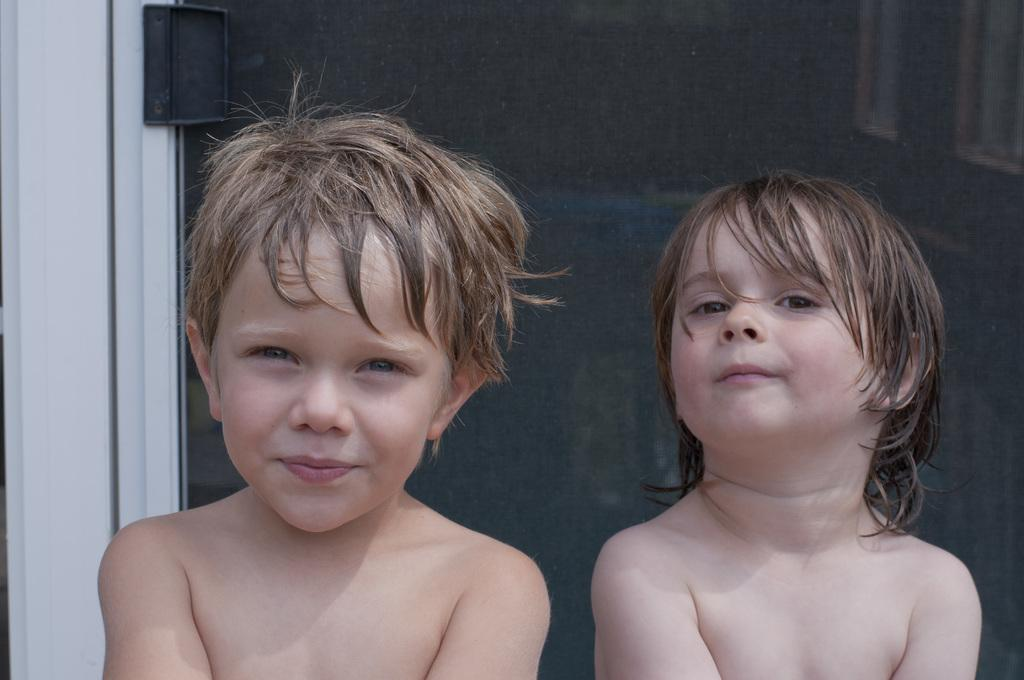How many children are present in the image? There are two children in the image. What is visible behind the children in the image? There is a glass door visible in the image. What type of pancake is being served on the edge of the vest in the image? There is no pancake or vest present in the image. 